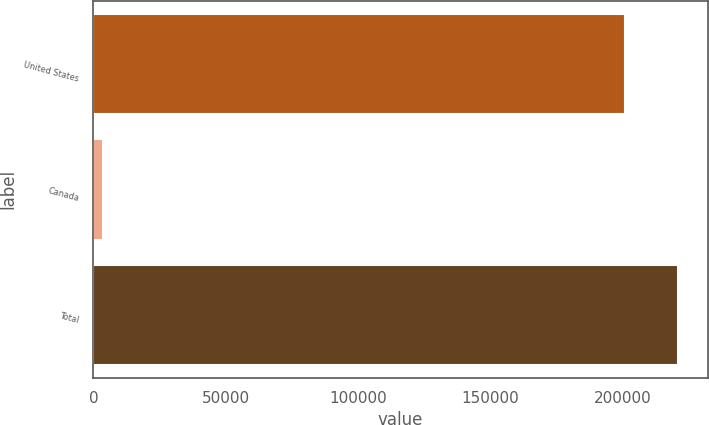Convert chart. <chart><loc_0><loc_0><loc_500><loc_500><bar_chart><fcel>United States<fcel>Canada<fcel>Total<nl><fcel>200767<fcel>3620<fcel>220916<nl></chart> 